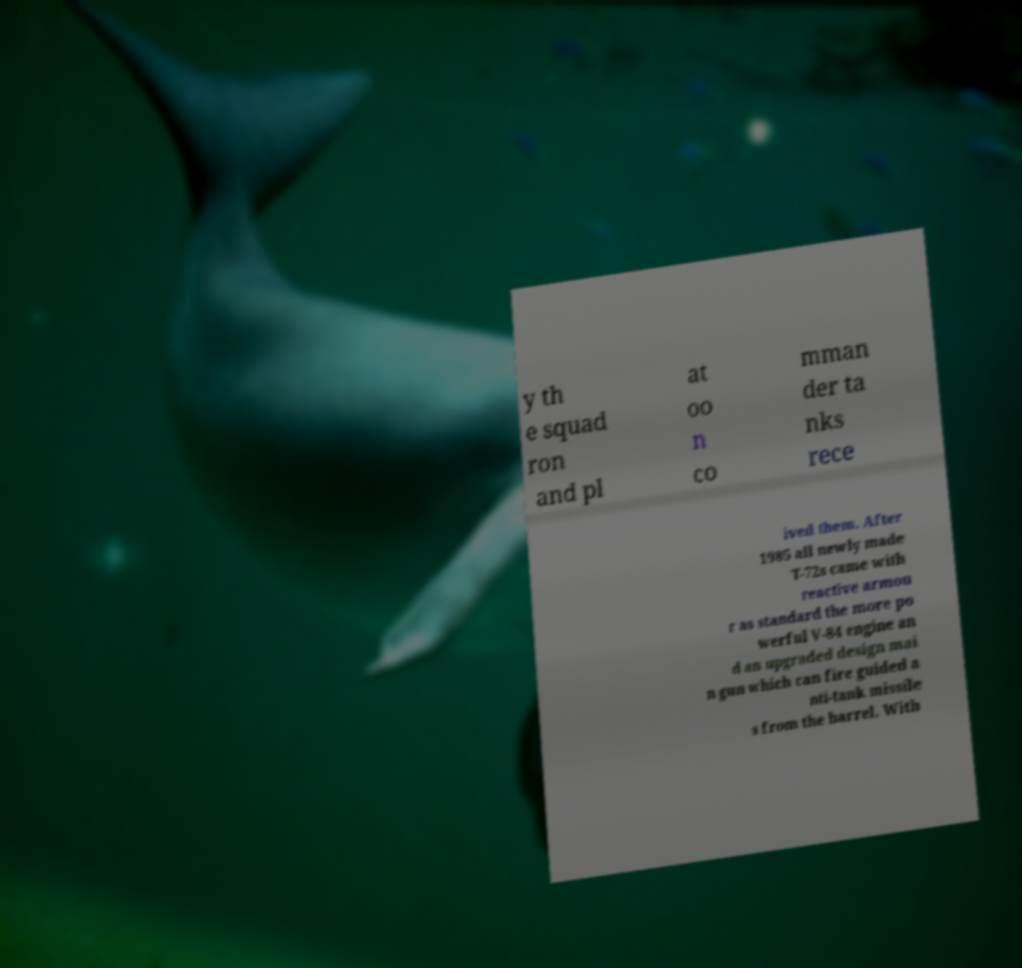There's text embedded in this image that I need extracted. Can you transcribe it verbatim? y th e squad ron and pl at oo n co mman der ta nks rece ived them. After 1985 all newly made T-72s came with reactive armou r as standard the more po werful V-84 engine an d an upgraded design mai n gun which can fire guided a nti-tank missile s from the barrel. With 